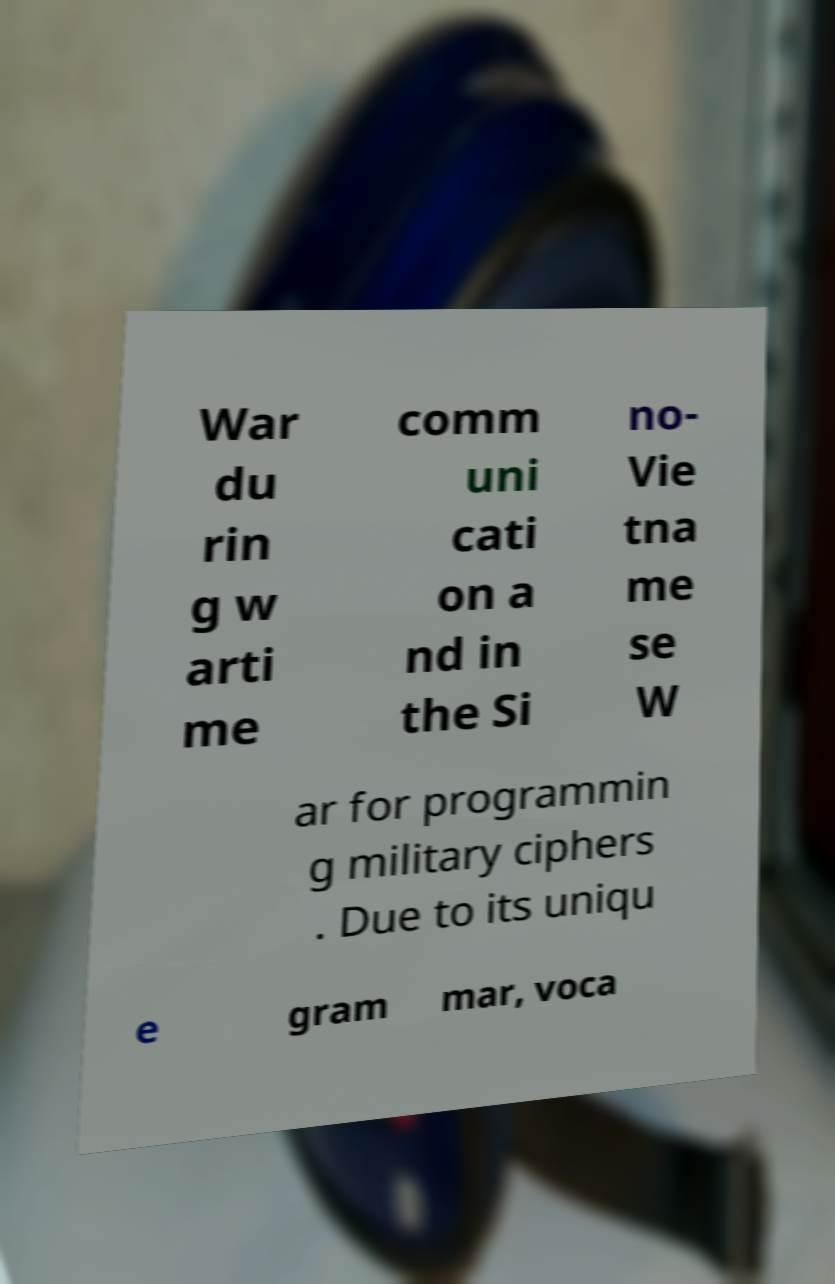Please read and relay the text visible in this image. What does it say? War du rin g w arti me comm uni cati on a nd in the Si no- Vie tna me se W ar for programmin g military ciphers . Due to its uniqu e gram mar, voca 